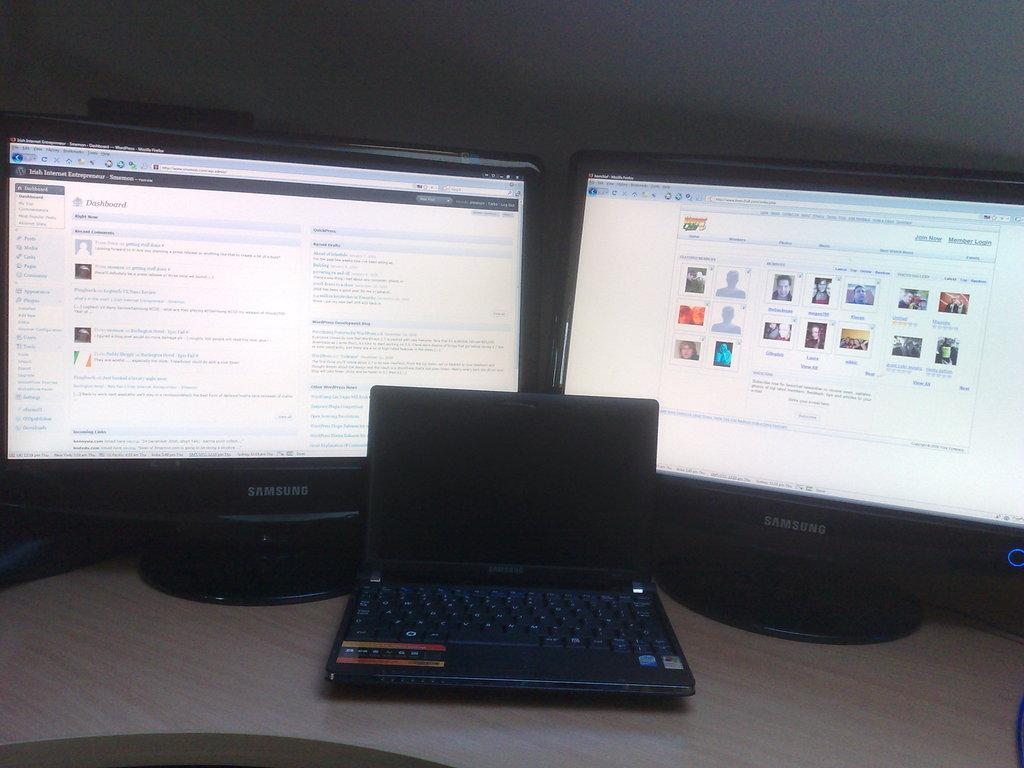What electronic devices are present on the table in the image? There are monitors and a laptop on the table in the image. Can you describe the wall visible in the background of the image? Unfortunately, the provided facts do not give any information about the wall, so we cannot describe it. What is the primary purpose of the devices on the table? The primary purpose of the devices on the table is likely for displaying information or working on tasks, given that they are monitors and a laptop. What type of son can be heard singing in the image? There is no son or singing present in the image; it only features electronic devices on a table and a wall in the background. 